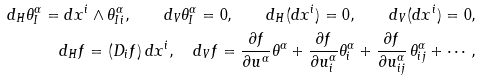<formula> <loc_0><loc_0><loc_500><loc_500>d _ { H } \theta _ { I } ^ { \alpha } = d x ^ { i } \wedge \theta ^ { \alpha } _ { I i } , \quad d _ { V } \theta ^ { \alpha } _ { I } = 0 , \quad d _ { H } ( d x ^ { i } ) = 0 , \quad d _ { V } ( d x ^ { i } ) = 0 , \\ d _ { H } f = ( D _ { i } f ) \, d x ^ { i } , \quad d _ { V } f = \frac { \partial f } { \partial u ^ { \alpha } } \theta ^ { \alpha } + \frac { \partial f } { \partial u ^ { \alpha } _ { i } } \theta ^ { \alpha } _ { i } + \frac { \partial f } { \partial u ^ { \alpha } _ { i j } } \, \theta ^ { \alpha } _ { i j } + \cdots \, ,</formula> 